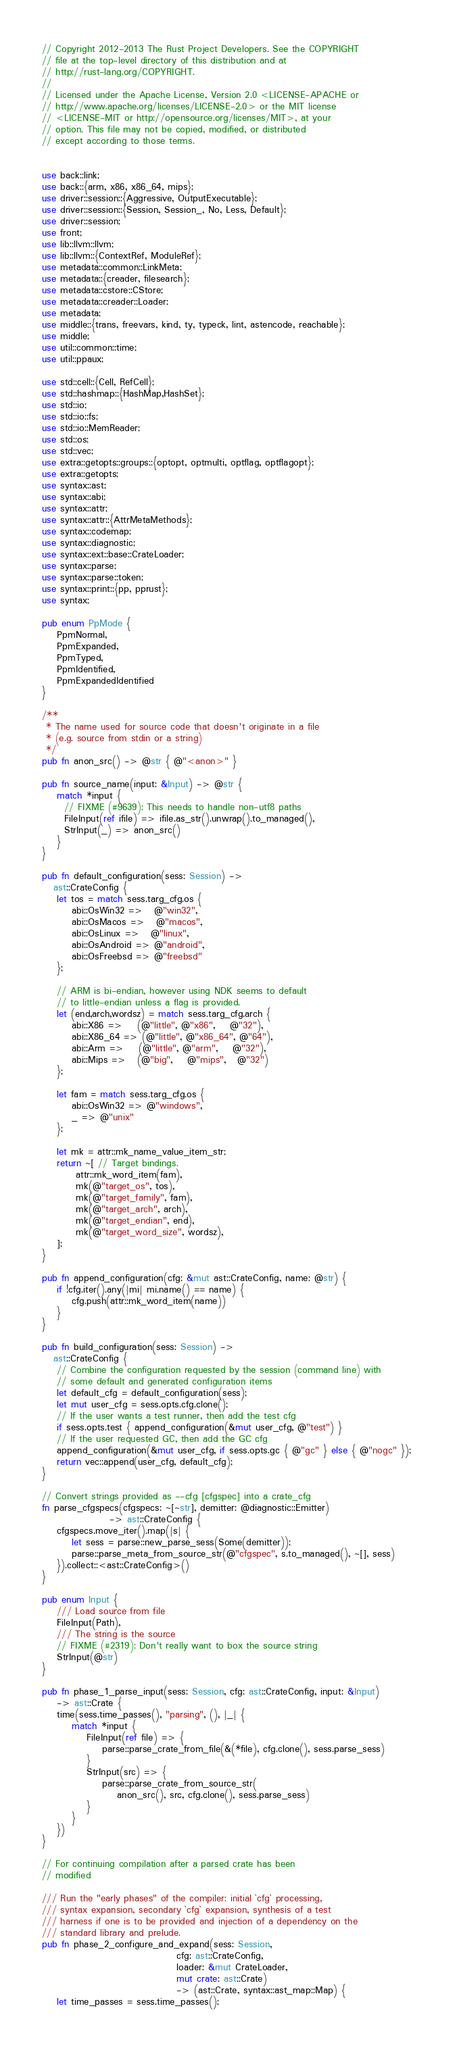<code> <loc_0><loc_0><loc_500><loc_500><_Rust_>// Copyright 2012-2013 The Rust Project Developers. See the COPYRIGHT
// file at the top-level directory of this distribution and at
// http://rust-lang.org/COPYRIGHT.
//
// Licensed under the Apache License, Version 2.0 <LICENSE-APACHE or
// http://www.apache.org/licenses/LICENSE-2.0> or the MIT license
// <LICENSE-MIT or http://opensource.org/licenses/MIT>, at your
// option. This file may not be copied, modified, or distributed
// except according to those terms.


use back::link;
use back::{arm, x86, x86_64, mips};
use driver::session::{Aggressive, OutputExecutable};
use driver::session::{Session, Session_, No, Less, Default};
use driver::session;
use front;
use lib::llvm::llvm;
use lib::llvm::{ContextRef, ModuleRef};
use metadata::common::LinkMeta;
use metadata::{creader, filesearch};
use metadata::cstore::CStore;
use metadata::creader::Loader;
use metadata;
use middle::{trans, freevars, kind, ty, typeck, lint, astencode, reachable};
use middle;
use util::common::time;
use util::ppaux;

use std::cell::{Cell, RefCell};
use std::hashmap::{HashMap,HashSet};
use std::io;
use std::io::fs;
use std::io::MemReader;
use std::os;
use std::vec;
use extra::getopts::groups::{optopt, optmulti, optflag, optflagopt};
use extra::getopts;
use syntax::ast;
use syntax::abi;
use syntax::attr;
use syntax::attr::{AttrMetaMethods};
use syntax::codemap;
use syntax::diagnostic;
use syntax::ext::base::CrateLoader;
use syntax::parse;
use syntax::parse::token;
use syntax::print::{pp, pprust};
use syntax;

pub enum PpMode {
    PpmNormal,
    PpmExpanded,
    PpmTyped,
    PpmIdentified,
    PpmExpandedIdentified
}

/**
 * The name used for source code that doesn't originate in a file
 * (e.g. source from stdin or a string)
 */
pub fn anon_src() -> @str { @"<anon>" }

pub fn source_name(input: &Input) -> @str {
    match *input {
      // FIXME (#9639): This needs to handle non-utf8 paths
      FileInput(ref ifile) => ifile.as_str().unwrap().to_managed(),
      StrInput(_) => anon_src()
    }
}

pub fn default_configuration(sess: Session) ->
   ast::CrateConfig {
    let tos = match sess.targ_cfg.os {
        abi::OsWin32 =>   @"win32",
        abi::OsMacos =>   @"macos",
        abi::OsLinux =>   @"linux",
        abi::OsAndroid => @"android",
        abi::OsFreebsd => @"freebsd"
    };

    // ARM is bi-endian, however using NDK seems to default
    // to little-endian unless a flag is provided.
    let (end,arch,wordsz) = match sess.targ_cfg.arch {
        abi::X86 =>    (@"little", @"x86",    @"32"),
        abi::X86_64 => (@"little", @"x86_64", @"64"),
        abi::Arm =>    (@"little", @"arm",    @"32"),
        abi::Mips =>   (@"big",    @"mips",   @"32")
    };

    let fam = match sess.targ_cfg.os {
        abi::OsWin32 => @"windows",
        _ => @"unix"
    };

    let mk = attr::mk_name_value_item_str;
    return ~[ // Target bindings.
         attr::mk_word_item(fam),
         mk(@"target_os", tos),
         mk(@"target_family", fam),
         mk(@"target_arch", arch),
         mk(@"target_endian", end),
         mk(@"target_word_size", wordsz),
    ];
}

pub fn append_configuration(cfg: &mut ast::CrateConfig, name: @str) {
    if !cfg.iter().any(|mi| mi.name() == name) {
        cfg.push(attr::mk_word_item(name))
    }
}

pub fn build_configuration(sess: Session) ->
   ast::CrateConfig {
    // Combine the configuration requested by the session (command line) with
    // some default and generated configuration items
    let default_cfg = default_configuration(sess);
    let mut user_cfg = sess.opts.cfg.clone();
    // If the user wants a test runner, then add the test cfg
    if sess.opts.test { append_configuration(&mut user_cfg, @"test") }
    // If the user requested GC, then add the GC cfg
    append_configuration(&mut user_cfg, if sess.opts.gc { @"gc" } else { @"nogc" });
    return vec::append(user_cfg, default_cfg);
}

// Convert strings provided as --cfg [cfgspec] into a crate_cfg
fn parse_cfgspecs(cfgspecs: ~[~str], demitter: @diagnostic::Emitter)
                  -> ast::CrateConfig {
    cfgspecs.move_iter().map(|s| {
        let sess = parse::new_parse_sess(Some(demitter));
        parse::parse_meta_from_source_str(@"cfgspec", s.to_managed(), ~[], sess)
    }).collect::<ast::CrateConfig>()
}

pub enum Input {
    /// Load source from file
    FileInput(Path),
    /// The string is the source
    // FIXME (#2319): Don't really want to box the source string
    StrInput(@str)
}

pub fn phase_1_parse_input(sess: Session, cfg: ast::CrateConfig, input: &Input)
    -> ast::Crate {
    time(sess.time_passes(), "parsing", (), |_| {
        match *input {
            FileInput(ref file) => {
                parse::parse_crate_from_file(&(*file), cfg.clone(), sess.parse_sess)
            }
            StrInput(src) => {
                parse::parse_crate_from_source_str(
                    anon_src(), src, cfg.clone(), sess.parse_sess)
            }
        }
    })
}

// For continuing compilation after a parsed crate has been
// modified

/// Run the "early phases" of the compiler: initial `cfg` processing,
/// syntax expansion, secondary `cfg` expansion, synthesis of a test
/// harness if one is to be provided and injection of a dependency on the
/// standard library and prelude.
pub fn phase_2_configure_and_expand(sess: Session,
                                    cfg: ast::CrateConfig,
                                    loader: &mut CrateLoader,
                                    mut crate: ast::Crate)
                                    -> (ast::Crate, syntax::ast_map::Map) {
    let time_passes = sess.time_passes();
</code> 